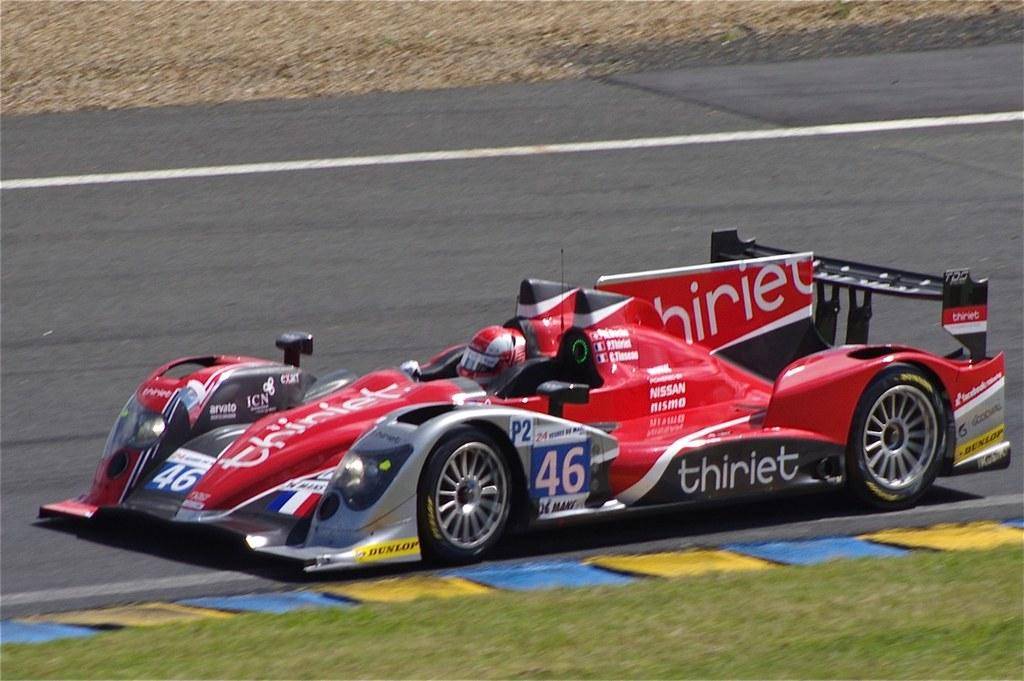Who is present in the image? There is a person in the image. What is the person wearing? The person is wearing a helmet. What type of vehicle is the person sitting in? The person is sitting in a sports car. Where is the sports car located? The sports car is on the road. What can be seen at the bottom of the image? There is grass visible at the bottom of the image. What type of furniture can be seen in the image? There is no furniture present in the image. Can you describe the downtown area in the image? The image does not depict a downtown area; it features a person in a sports car on the road. 